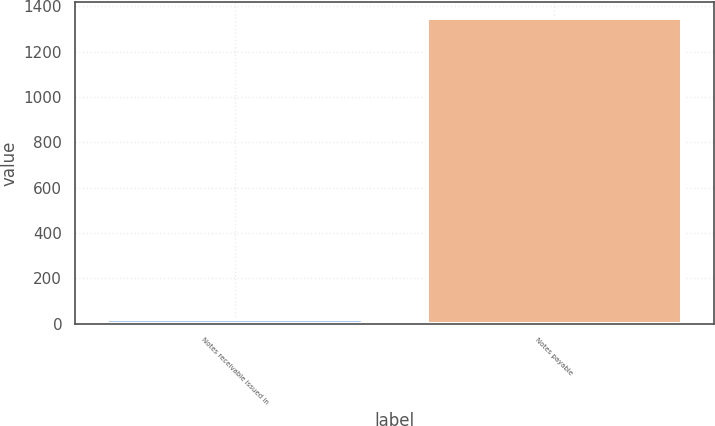Convert chart to OTSL. <chart><loc_0><loc_0><loc_500><loc_500><bar_chart><fcel>Notes receivable issued in<fcel>Notes payable<nl><fcel>22.2<fcel>1350<nl></chart> 